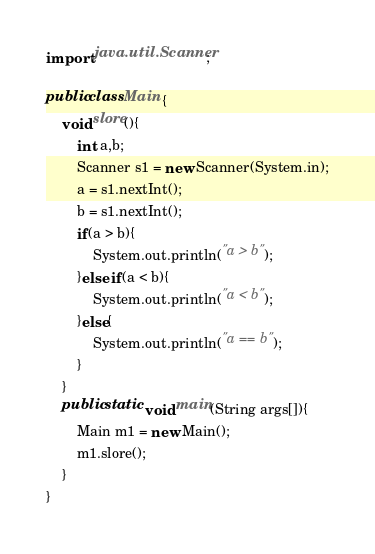Convert code to text. <code><loc_0><loc_0><loc_500><loc_500><_Java_>import java.util.Scanner;

public class Main {
	void slore(){
		int a,b;
		Scanner s1 = new Scanner(System.in);
		a = s1.nextInt();
		b = s1.nextInt();
		if(a > b){
			System.out.println("a > b");
		}else if(a < b){
			System.out.println("a < b");
		}else{
			System.out.println("a == b");
		}
	}
	public static void main(String args[]){
		Main m1 = new Main();
		m1.slore();
	}
}</code> 